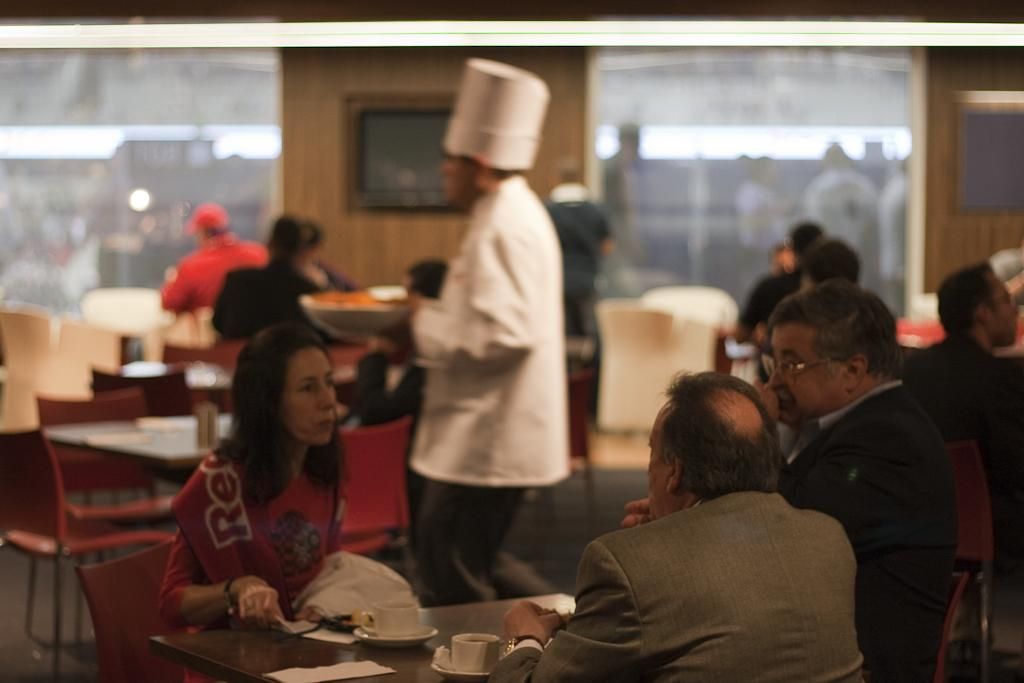What are the people in the image doing? The people in the image are sitting on chairs. Can you describe the man in the image? There is a man standing in the image, and he is holding a bowl in his hand. What type of powder is the man sprinkling on the mailbox in the image? There is no mailbox or powder present in the image. How many family members can be seen in the image? The provided facts do not mention any family members, so we cannot determine the number of family members in the image. 